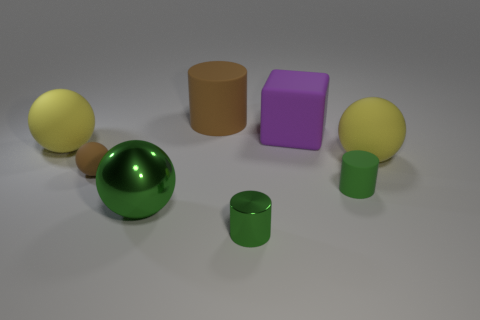Add 1 large green spheres. How many objects exist? 9 Subtract all cylinders. How many objects are left? 5 Add 3 tiny brown rubber balls. How many tiny brown rubber balls are left? 4 Add 2 large cylinders. How many large cylinders exist? 3 Subtract 0 yellow cubes. How many objects are left? 8 Subtract all big gray metal cubes. Subtract all green rubber cylinders. How many objects are left? 7 